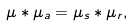Convert formula to latex. <formula><loc_0><loc_0><loc_500><loc_500>\mu \ast \mu _ { a } = \mu _ { s } \ast \mu _ { r } ,</formula> 